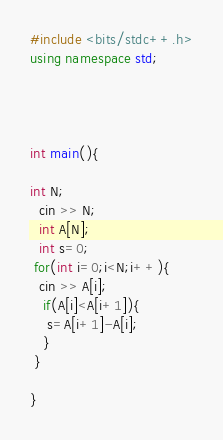Convert code to text. <code><loc_0><loc_0><loc_500><loc_500><_C++_>#include <bits/stdc++.h>
using namespace std;




int main(){

int N;
  cin >> N;
  int A[N];
  int s=0;
 for(int i=0;i<N;i++){
  cin >> A[i];
   if(A[i]<A[i+1]){
    s=A[i+1]-A[i];
   }
 }
  
}
</code> 